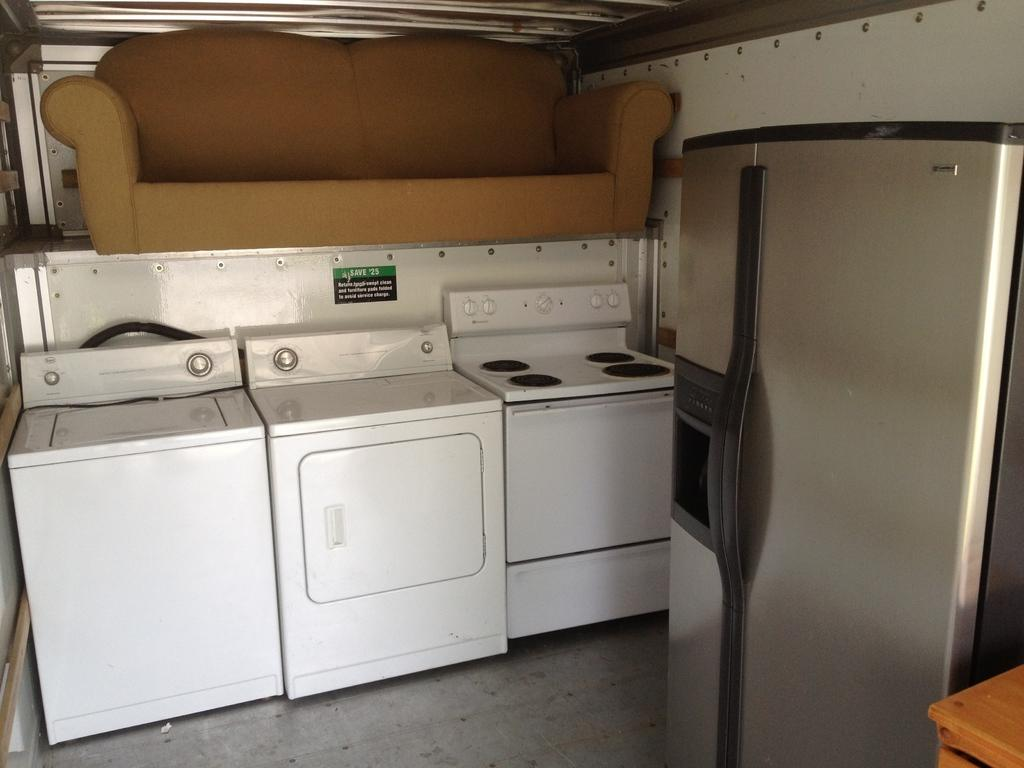What type of appliance is visible in the image? There is a washing machine in the image. What other appliance can be seen in the image? There is a dryer in the image. What cooking appliance is present in the image? There is a stove in the image. What type of furniture is in the image? There is a sofa in the image. What appliance is used for storing food in the image? There is a refrigerator in the image. What type of glass can be seen shattering during a thunderstorm in the image? There is no glass or thunderstorm present in the image; it features appliances and furniture. 